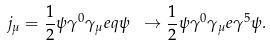Convert formula to latex. <formula><loc_0><loc_0><loc_500><loc_500>j _ { \mu } = \frac { 1 } { 2 } \psi \gamma ^ { 0 } \gamma _ { \mu } e q \psi \ \to \frac { 1 } { 2 } \psi \gamma ^ { 0 } \gamma _ { \mu } e \gamma ^ { 5 } \psi .</formula> 